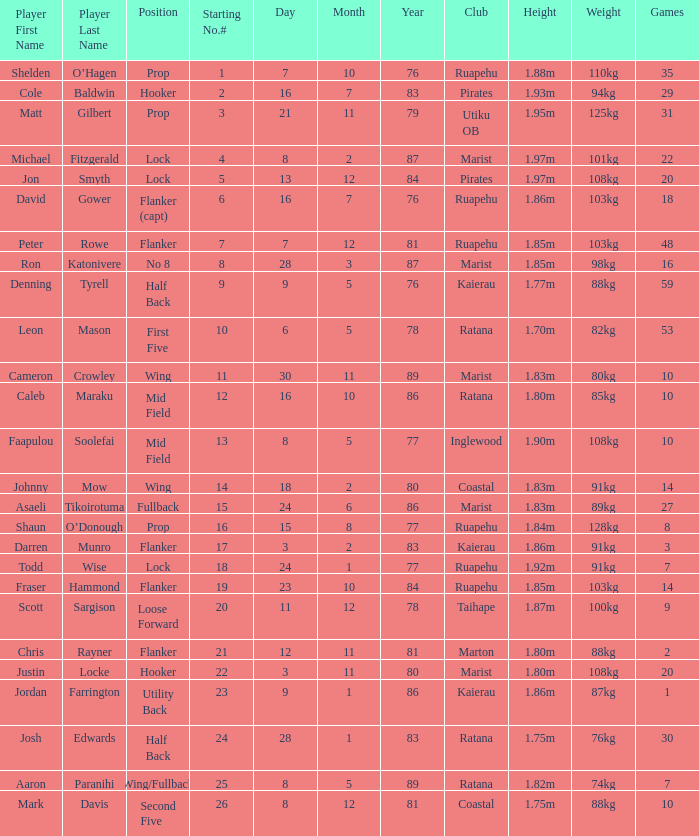How many games were played where the height of the player is 1.92m? 1.0. 